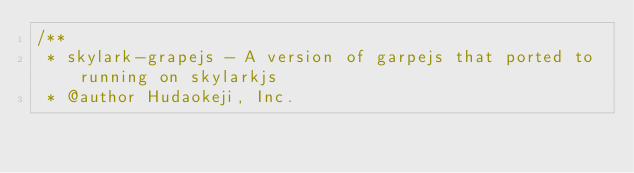<code> <loc_0><loc_0><loc_500><loc_500><_JavaScript_>/**
 * skylark-grapejs - A version of garpejs that ported to running on skylarkjs
 * @author Hudaokeji, Inc.</code> 